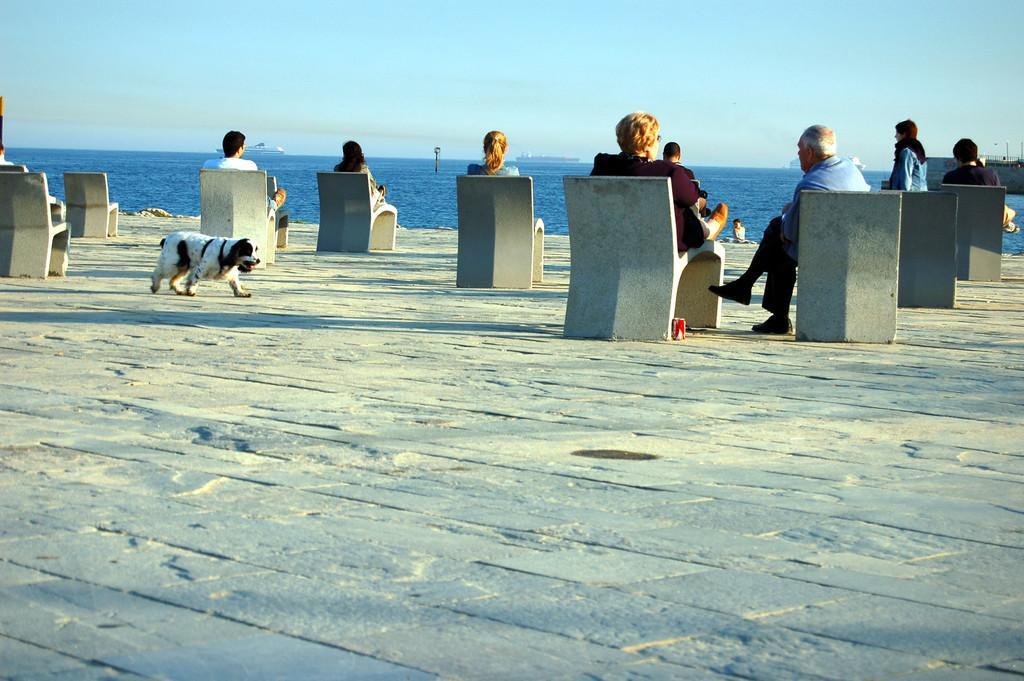In one or two sentences, can you explain what this image depicts? In this picture there are people those who are sitting on the chairs at the top side of the image and there is a dog on the left side of the image, there is water in the background area of the image. 